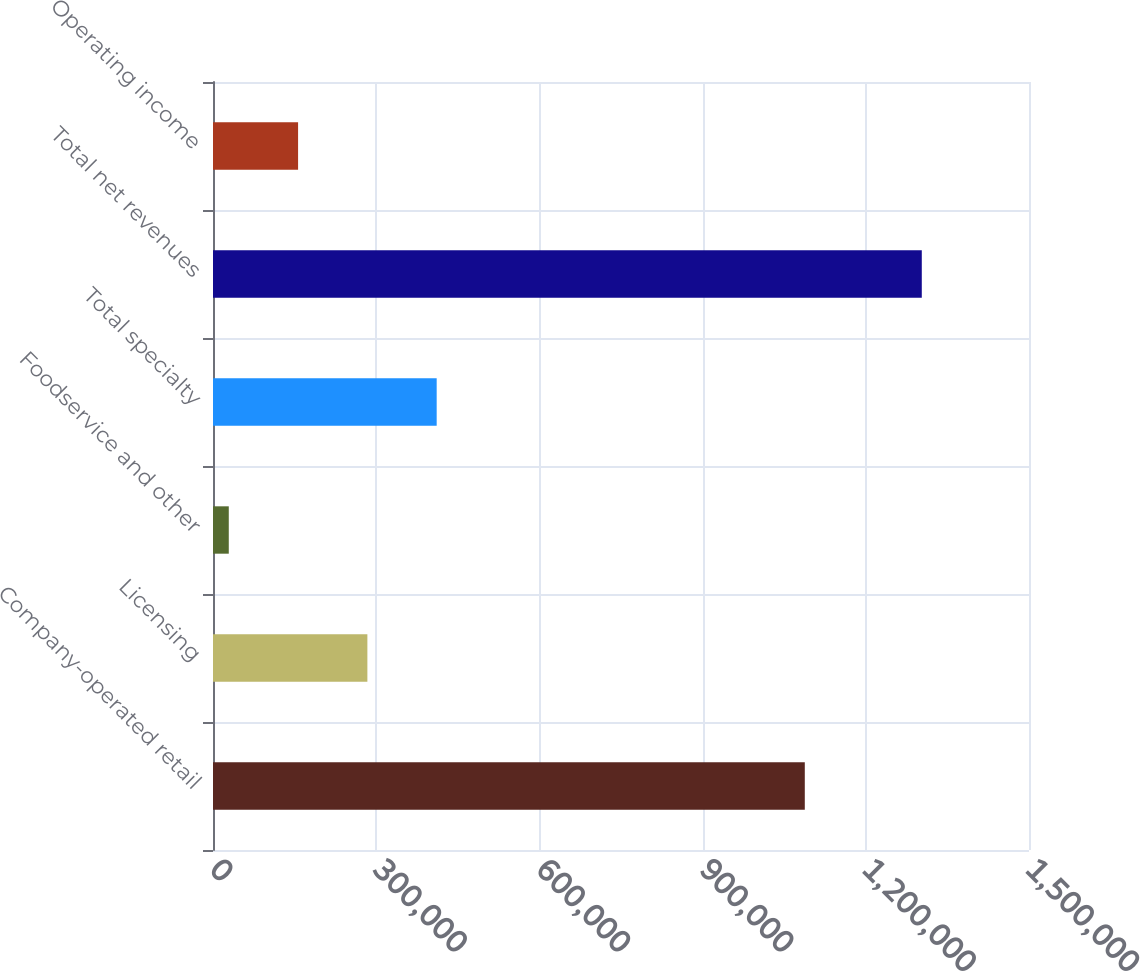<chart> <loc_0><loc_0><loc_500><loc_500><bar_chart><fcel>Company-operated retail<fcel>Licensing<fcel>Foodservice and other<fcel>Total specialty<fcel>Total net revenues<fcel>Operating income<nl><fcel>1.08786e+06<fcel>283788<fcel>29006<fcel>411178<fcel>1.30291e+06<fcel>156397<nl></chart> 